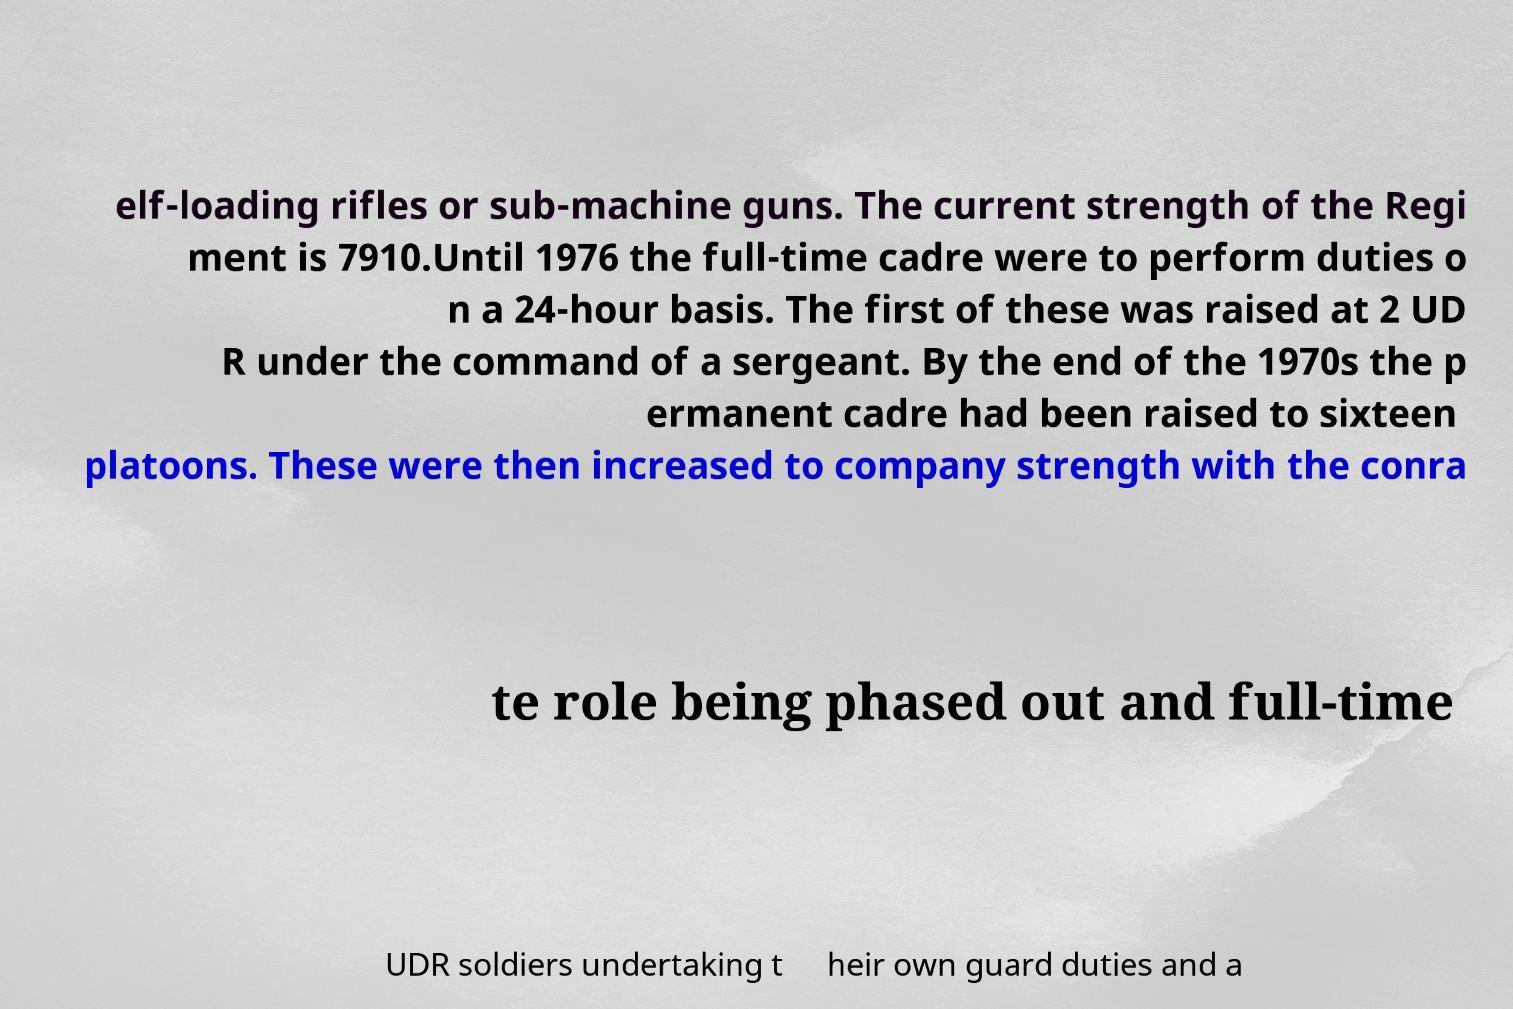What messages or text are displayed in this image? I need them in a readable, typed format. elf-loading rifles or sub-machine guns. The current strength of the Regi ment is 7910.Until 1976 the full-time cadre were to perform duties o n a 24-hour basis. The first of these was raised at 2 UD R under the command of a sergeant. By the end of the 1970s the p ermanent cadre had been raised to sixteen platoons. These were then increased to company strength with the conra te role being phased out and full-time UDR soldiers undertaking t heir own guard duties and a 